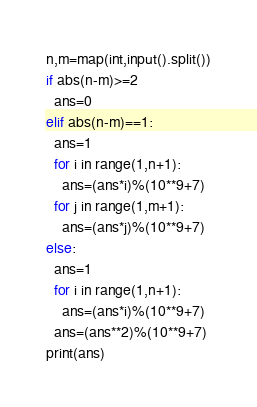<code> <loc_0><loc_0><loc_500><loc_500><_Python_>n,m=map(int,input().split())
if abs(n-m)>=2
  ans=0
elif abs(n-m)==1:
  ans=1
  for i in range(1,n+1):
    ans=(ans*i)%(10**9+7)
  for j in range(1,m+1):
    ans=(ans*j)%(10**9+7)
else:
  ans=1
  for i in range(1,n+1):
    ans=(ans*i)%(10**9+7)
  ans=(ans**2)%(10**9+7)
print(ans)</code> 